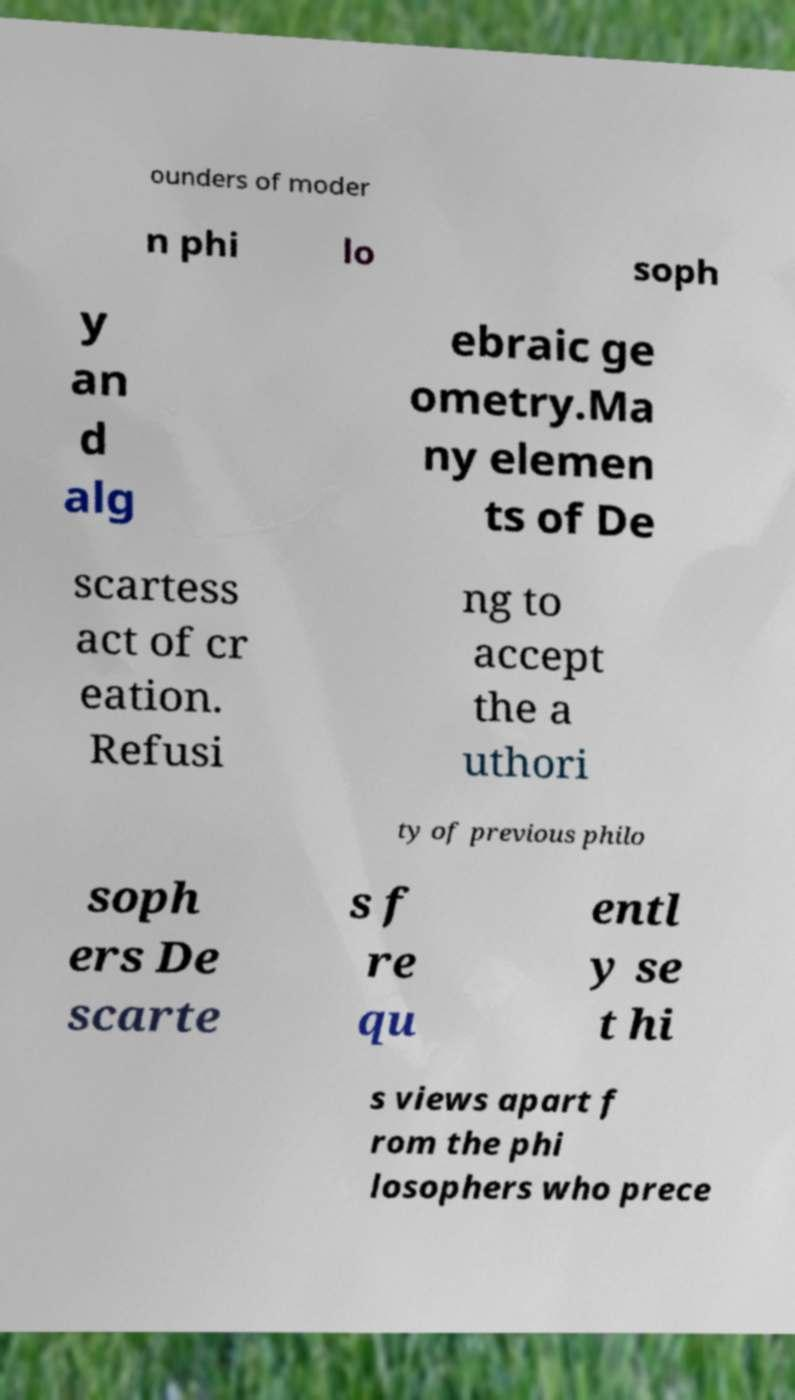Can you accurately transcribe the text from the provided image for me? ounders of moder n phi lo soph y an d alg ebraic ge ometry.Ma ny elemen ts of De scartess act of cr eation. Refusi ng to accept the a uthori ty of previous philo soph ers De scarte s f re qu entl y se t hi s views apart f rom the phi losophers who prece 